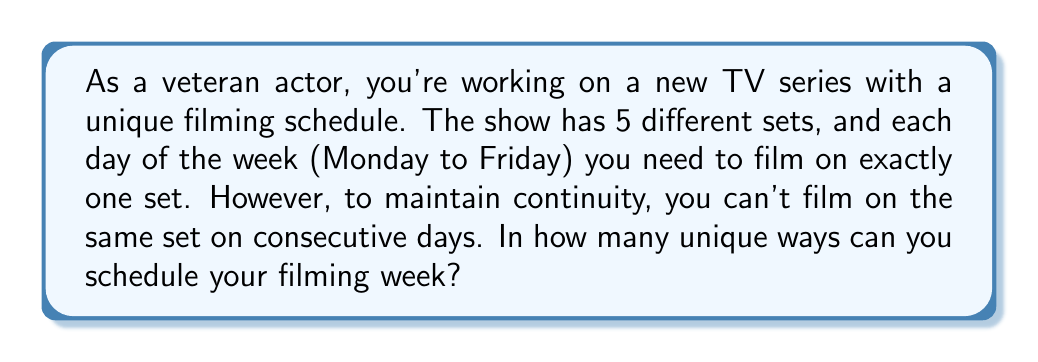Help me with this question. Let's approach this step-by-step:

1) We can think of this as a sequence of 5 choices (one for each day), where each choice is from the 5 available sets.

2) For the first day (Monday), we have all 5 sets available. So there are 5 choices for the first day.

3) For each subsequent day, we can't use the set used on the previous day. This means we have 4 choices for each of these days.

4) This scenario fits the multiplication principle of counting. We multiply the number of choices for each day:

   $$5 \times 4 \times 4 \times 4 \times 4$$

5) This can be written as:

   $$5 \times 4^4$$

6) Calculating this:
   $$5 \times 4^4 = 5 \times 256 = 1280$$

Therefore, there are 1280 unique ways to schedule the filming week under these constraints.
Answer: 1280 